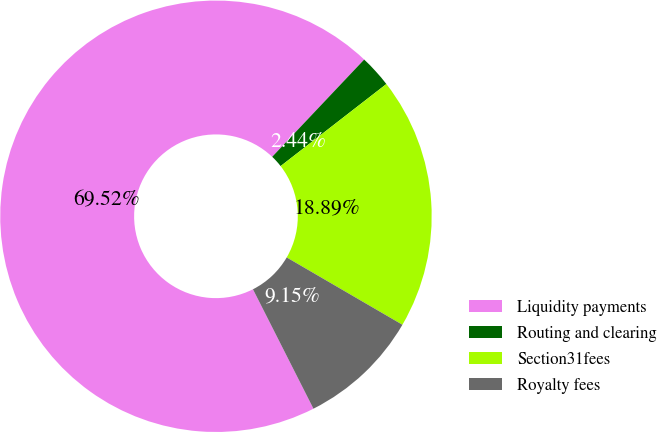Convert chart. <chart><loc_0><loc_0><loc_500><loc_500><pie_chart><fcel>Liquidity payments<fcel>Routing and clearing<fcel>Section31fees<fcel>Royalty fees<nl><fcel>69.52%<fcel>2.44%<fcel>18.89%<fcel>9.15%<nl></chart> 